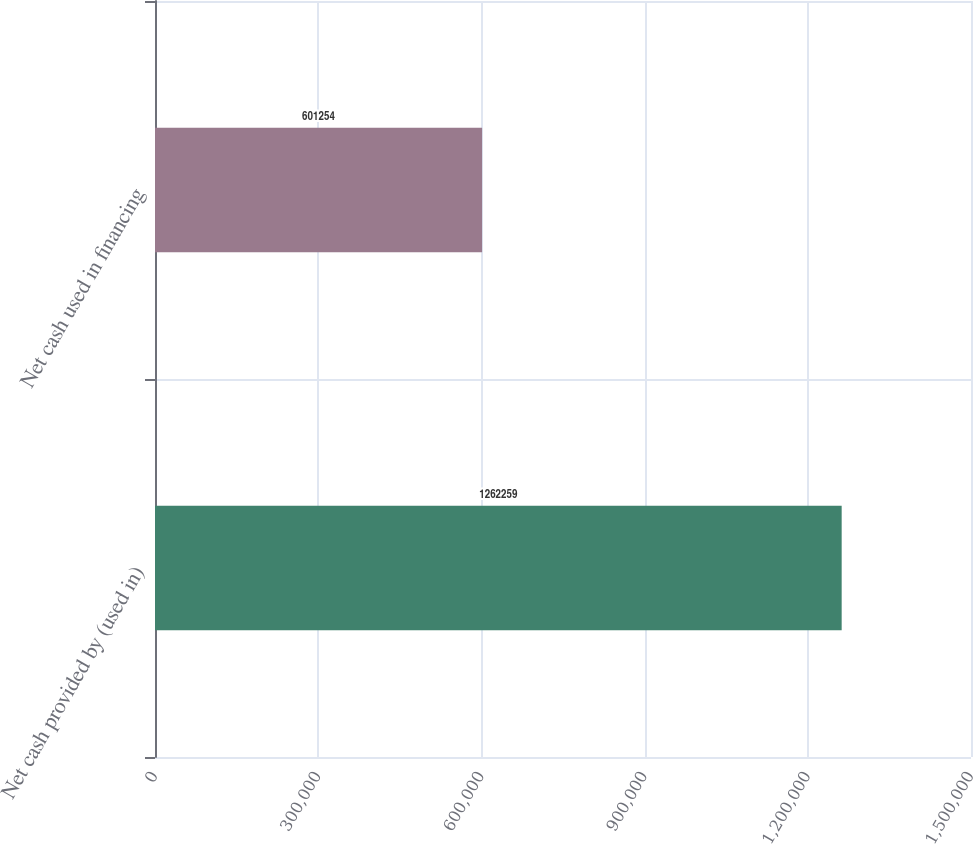Convert chart to OTSL. <chart><loc_0><loc_0><loc_500><loc_500><bar_chart><fcel>Net cash provided by (used in)<fcel>Net cash used in financing<nl><fcel>1.26226e+06<fcel>601254<nl></chart> 